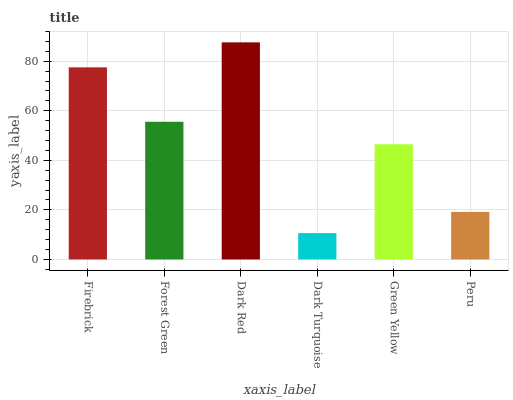Is Dark Turquoise the minimum?
Answer yes or no. Yes. Is Dark Red the maximum?
Answer yes or no. Yes. Is Forest Green the minimum?
Answer yes or no. No. Is Forest Green the maximum?
Answer yes or no. No. Is Firebrick greater than Forest Green?
Answer yes or no. Yes. Is Forest Green less than Firebrick?
Answer yes or no. Yes. Is Forest Green greater than Firebrick?
Answer yes or no. No. Is Firebrick less than Forest Green?
Answer yes or no. No. Is Forest Green the high median?
Answer yes or no. Yes. Is Green Yellow the low median?
Answer yes or no. Yes. Is Peru the high median?
Answer yes or no. No. Is Forest Green the low median?
Answer yes or no. No. 